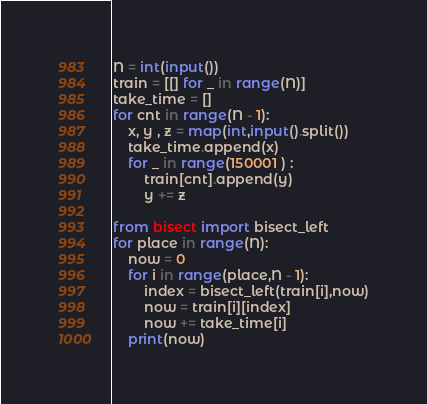<code> <loc_0><loc_0><loc_500><loc_500><_Python_>N = int(input())
train = [[] for _ in range(N)]
take_time = []
for cnt in range(N - 1):
    x, y , z = map(int,input().split())
    take_time.append(x)
    for _ in range(150001 ) :
        train[cnt].append(y)
        y += z

from bisect import bisect_left
for place in range(N):
    now = 0
    for i in range(place,N - 1):
        index = bisect_left(train[i],now)
        now = train[i][index]
        now += take_time[i]
    print(now)

</code> 